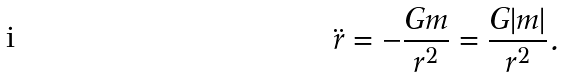<formula> <loc_0><loc_0><loc_500><loc_500>\ddot { r } = - \frac { G m } { r ^ { 2 } } = \frac { G | m | } { r ^ { 2 } } .</formula> 